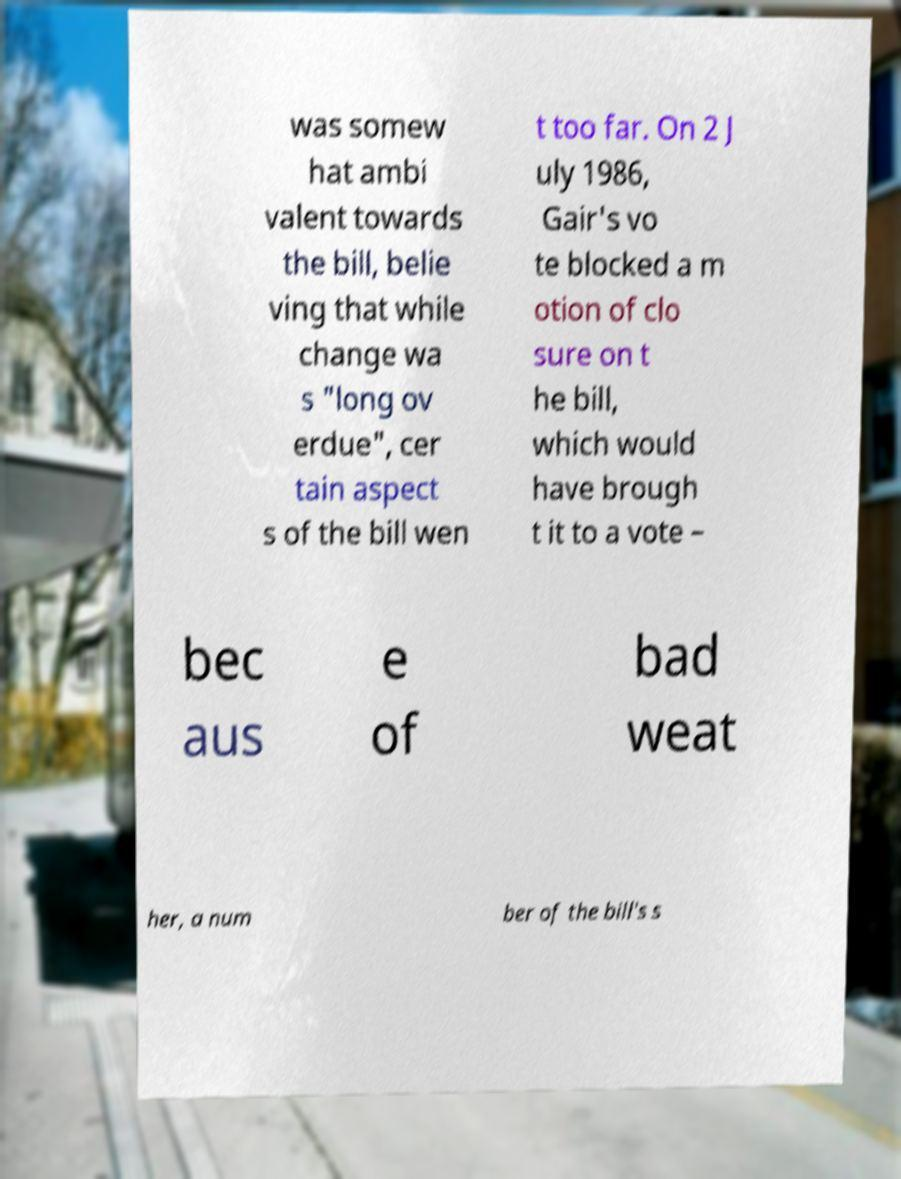Could you extract and type out the text from this image? was somew hat ambi valent towards the bill, belie ving that while change wa s "long ov erdue", cer tain aspect s of the bill wen t too far. On 2 J uly 1986, Gair's vo te blocked a m otion of clo sure on t he bill, which would have brough t it to a vote – bec aus e of bad weat her, a num ber of the bill's s 